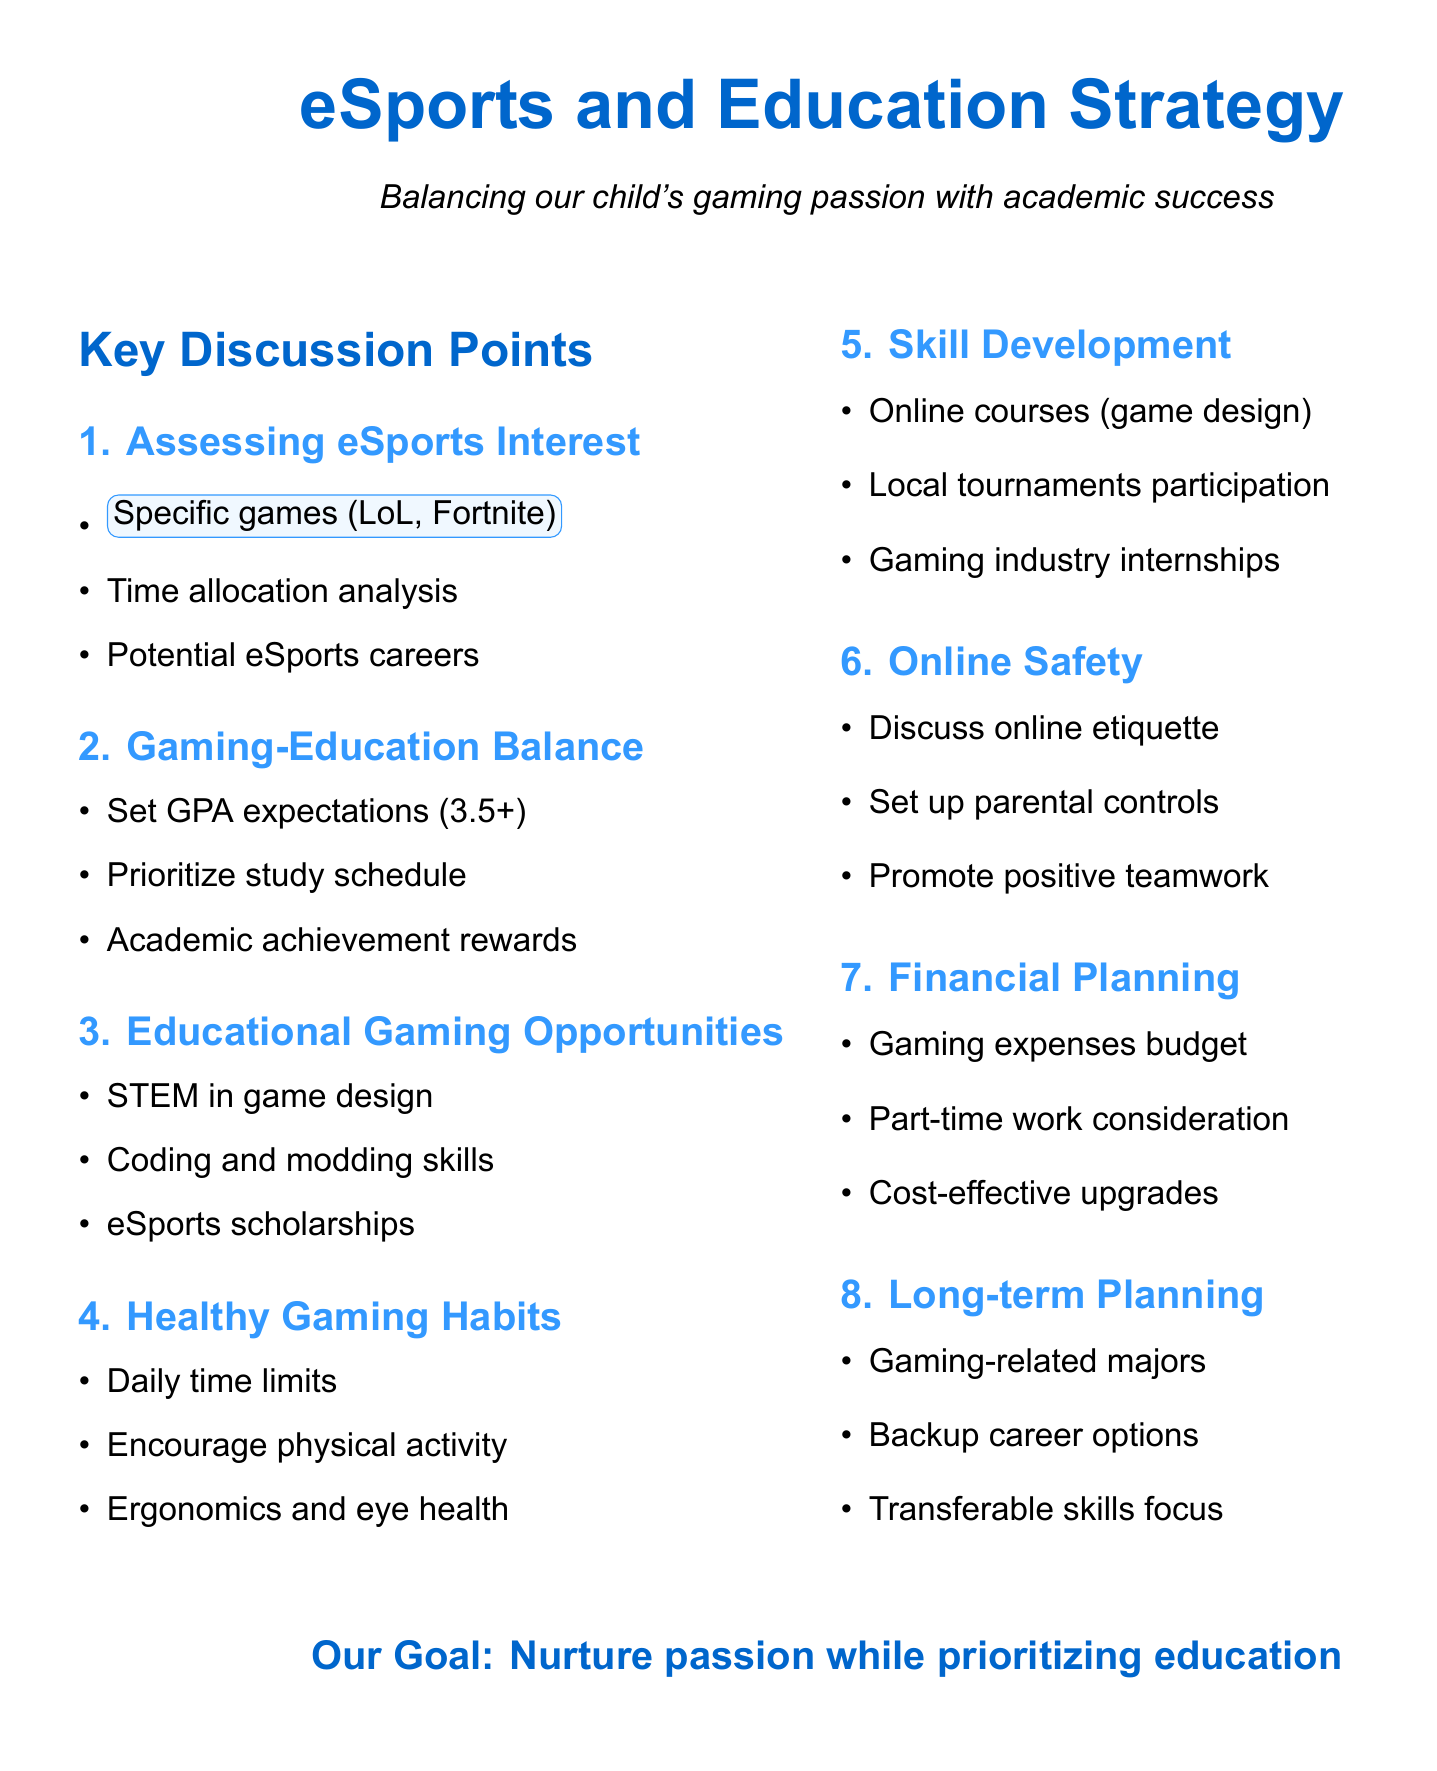What is the minimum GPA expectation for our child? The document specifies a minimum GPA of 3.5 that should be maintained.
Answer: 3.5 Which eSports scholarship universities are mentioned? The agenda discusses eSports scholarships at UC Irvine and Ohio State.
Answer: UC Irvine, Ohio State What are the suggested daily time limits for gaming? The document recommends daily time limits of 2 hours on weekdays and 4 hours on weekends.
Answer: 2 hours on weekdays, 4 hours on weekends Which skill development opportunity is related to local engagement? Encouraging participation in local gaming tournaments or clubs is listed as a skill development opportunity.
Answer: Local tournaments or clubs What should be established to promote online safety? The document suggests setting up parental controls on gaming platforms to promote online safety.
Answer: Parental controls 